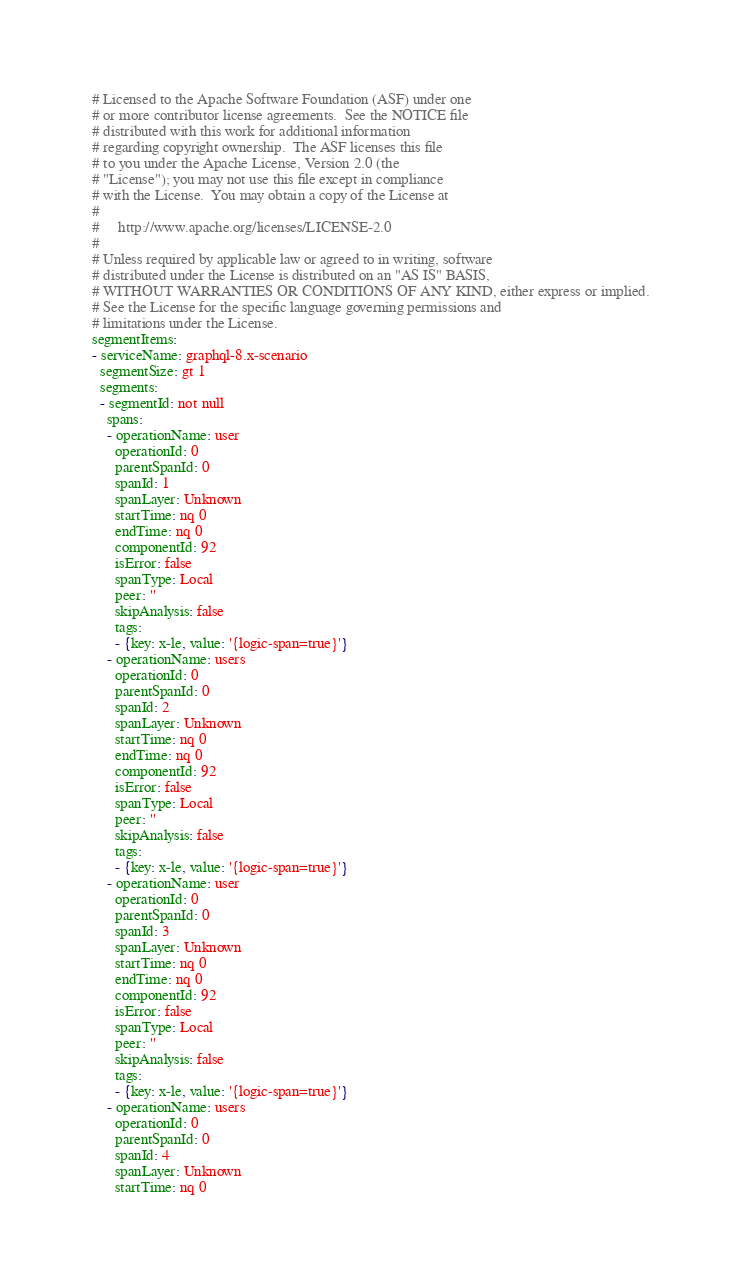Convert code to text. <code><loc_0><loc_0><loc_500><loc_500><_YAML_># Licensed to the Apache Software Foundation (ASF) under one
# or more contributor license agreements.  See the NOTICE file
# distributed with this work for additional information
# regarding copyright ownership.  The ASF licenses this file
# to you under the Apache License, Version 2.0 (the
# "License"); you may not use this file except in compliance
# with the License.  You may obtain a copy of the License at
#
#     http://www.apache.org/licenses/LICENSE-2.0
#
# Unless required by applicable law or agreed to in writing, software
# distributed under the License is distributed on an "AS IS" BASIS,
# WITHOUT WARRANTIES OR CONDITIONS OF ANY KIND, either express or implied.
# See the License for the specific language governing permissions and
# limitations under the License.
segmentItems:
- serviceName: graphql-8.x-scenario
  segmentSize: gt 1
  segments:
  - segmentId: not null
    spans:
    - operationName: user
      operationId: 0
      parentSpanId: 0
      spanId: 1
      spanLayer: Unknown
      startTime: nq 0
      endTime: nq 0
      componentId: 92
      isError: false
      spanType: Local
      peer: ''
      skipAnalysis: false
      tags:
      - {key: x-le, value: '{logic-span=true}'}
    - operationName: users
      operationId: 0
      parentSpanId: 0
      spanId: 2
      spanLayer: Unknown
      startTime: nq 0
      endTime: nq 0
      componentId: 92
      isError: false
      spanType: Local
      peer: ''
      skipAnalysis: false
      tags:
      - {key: x-le, value: '{logic-span=true}'}
    - operationName: user
      operationId: 0
      parentSpanId: 0
      spanId: 3
      spanLayer: Unknown
      startTime: nq 0
      endTime: nq 0
      componentId: 92
      isError: false
      spanType: Local
      peer: ''
      skipAnalysis: false
      tags:
      - {key: x-le, value: '{logic-span=true}'}
    - operationName: users
      operationId: 0
      parentSpanId: 0
      spanId: 4
      spanLayer: Unknown
      startTime: nq 0</code> 